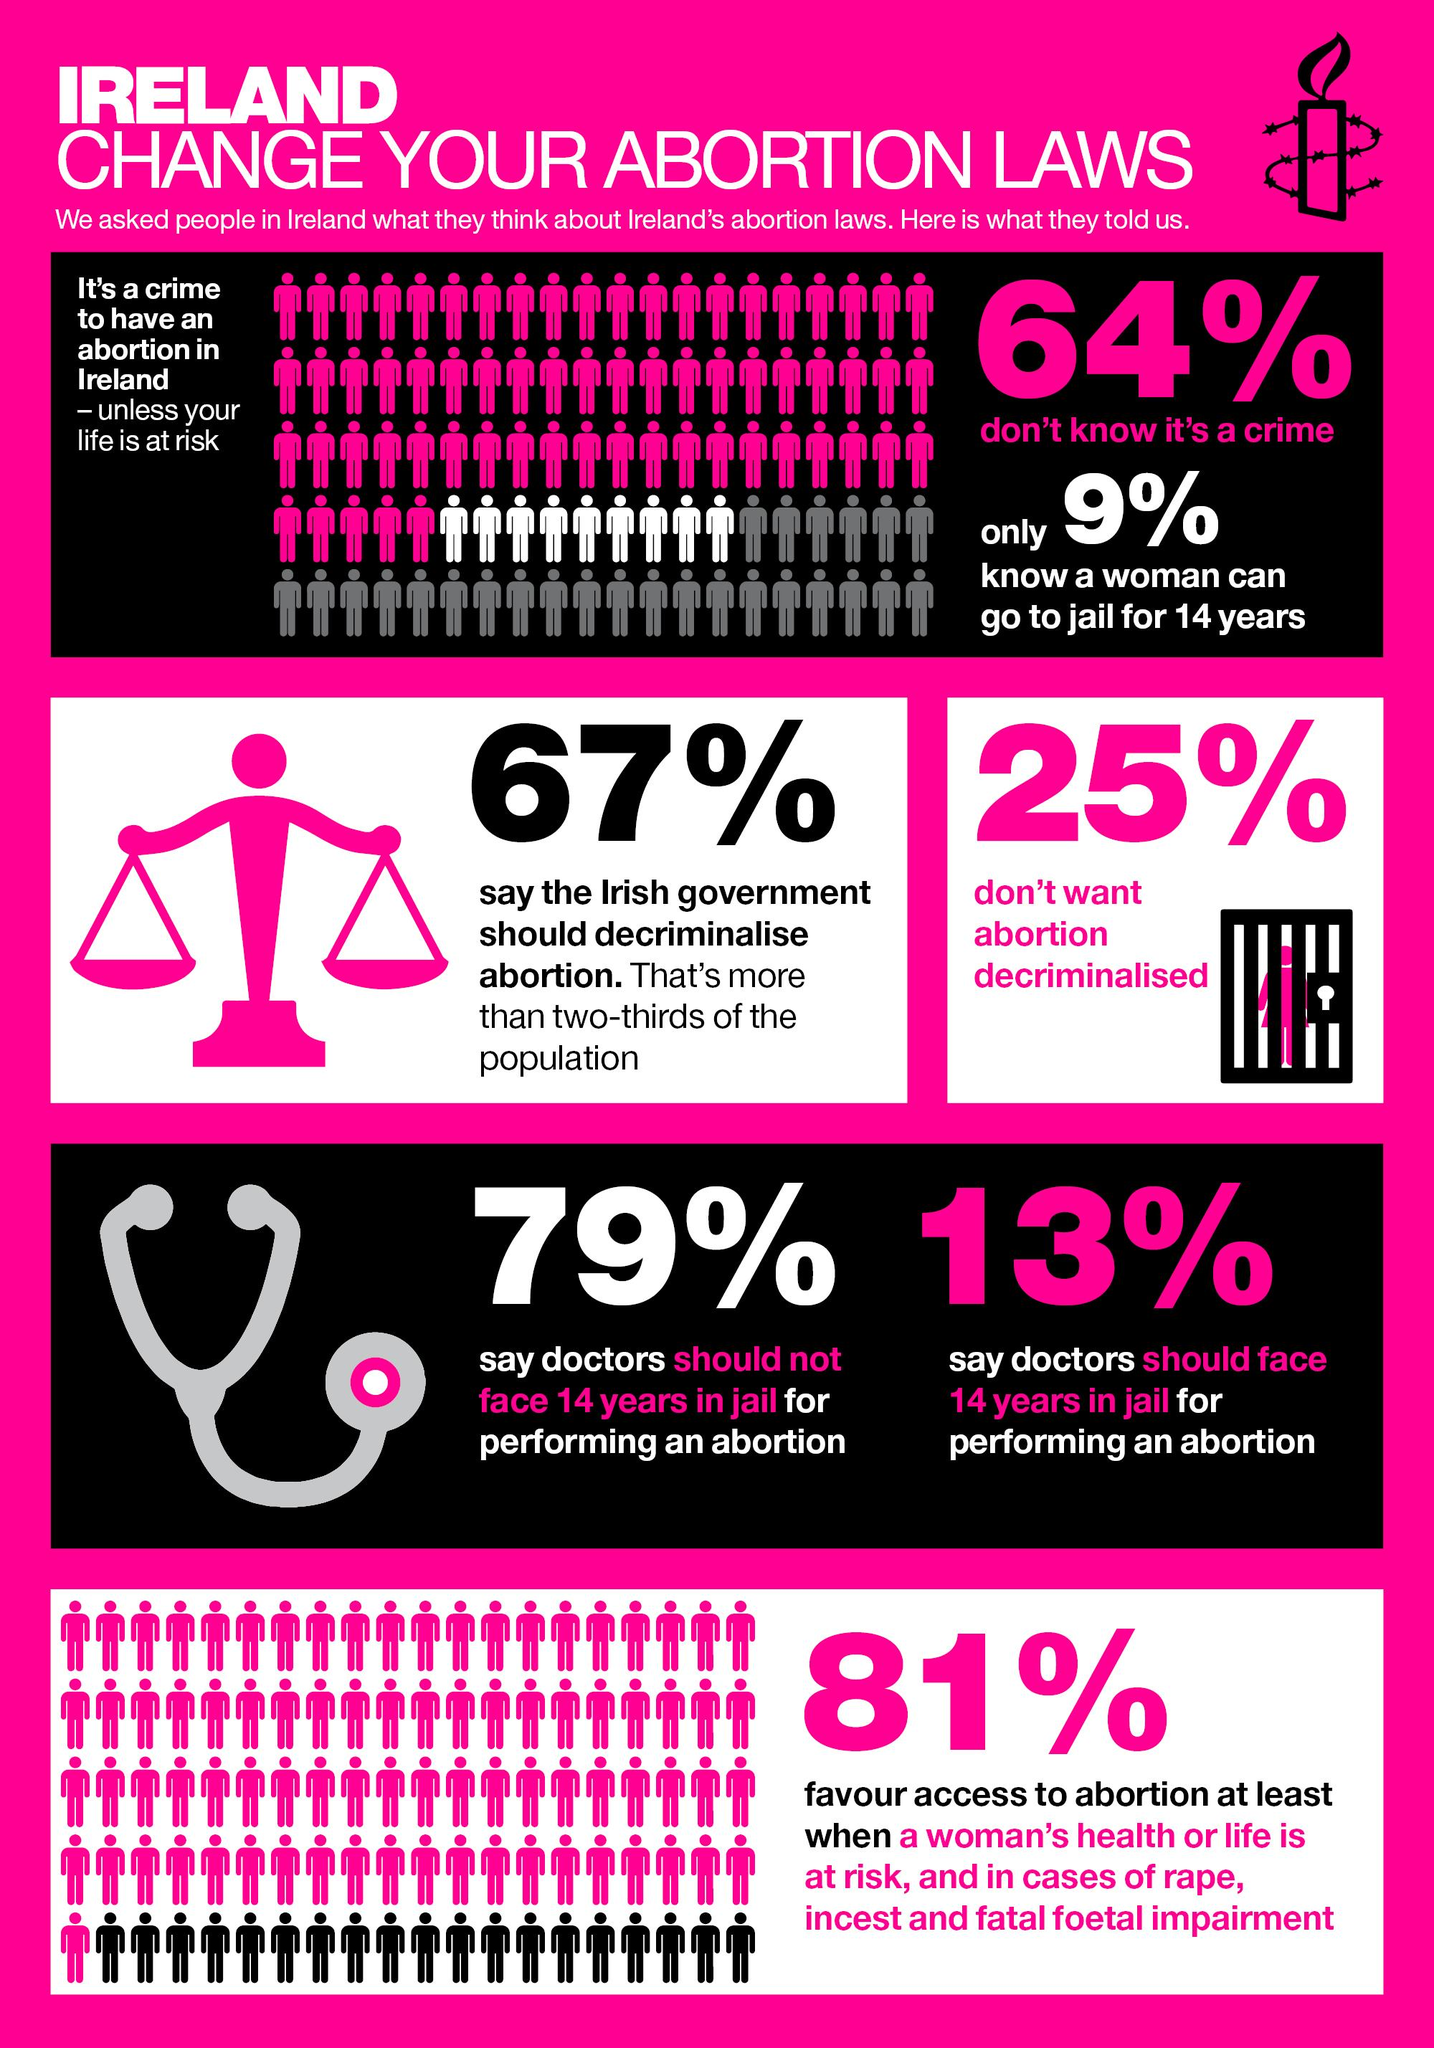Outline some significant characteristics in this image. Si se dice que el aborto debe despenalizarse, el 67% de la gente lo piensa así. Based on a recent survey, it is clear that two-thirds of the Irish population believe that the government should decriminalize abortion. According to a recent survey, 64% of people in Ireland are not aware that abortion is a crime. Abortion is only allowed in Ireland in exceptional situations where a woman's life is at risk. It is reported that 13% of people hold the view that doctors should face jail term for performing abortion. 